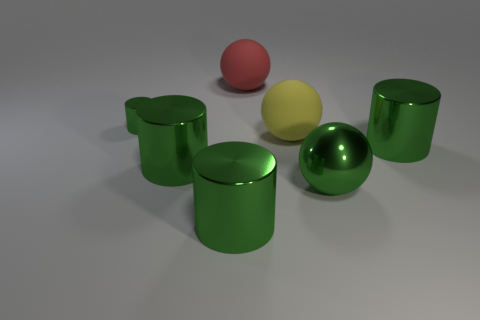Subtract all green cylinders. How many were subtracted if there are2green cylinders left? 2 Add 2 tiny yellow cylinders. How many objects exist? 9 Subtract all cylinders. How many objects are left? 3 Add 2 green metal things. How many green metal things are left? 7 Add 4 big yellow things. How many big yellow things exist? 5 Subtract 0 red blocks. How many objects are left? 7 Subtract all green shiny balls. Subtract all small red cubes. How many objects are left? 6 